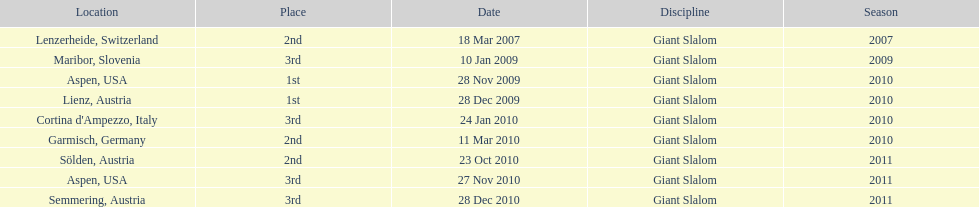How many races were in 2010? 5. 